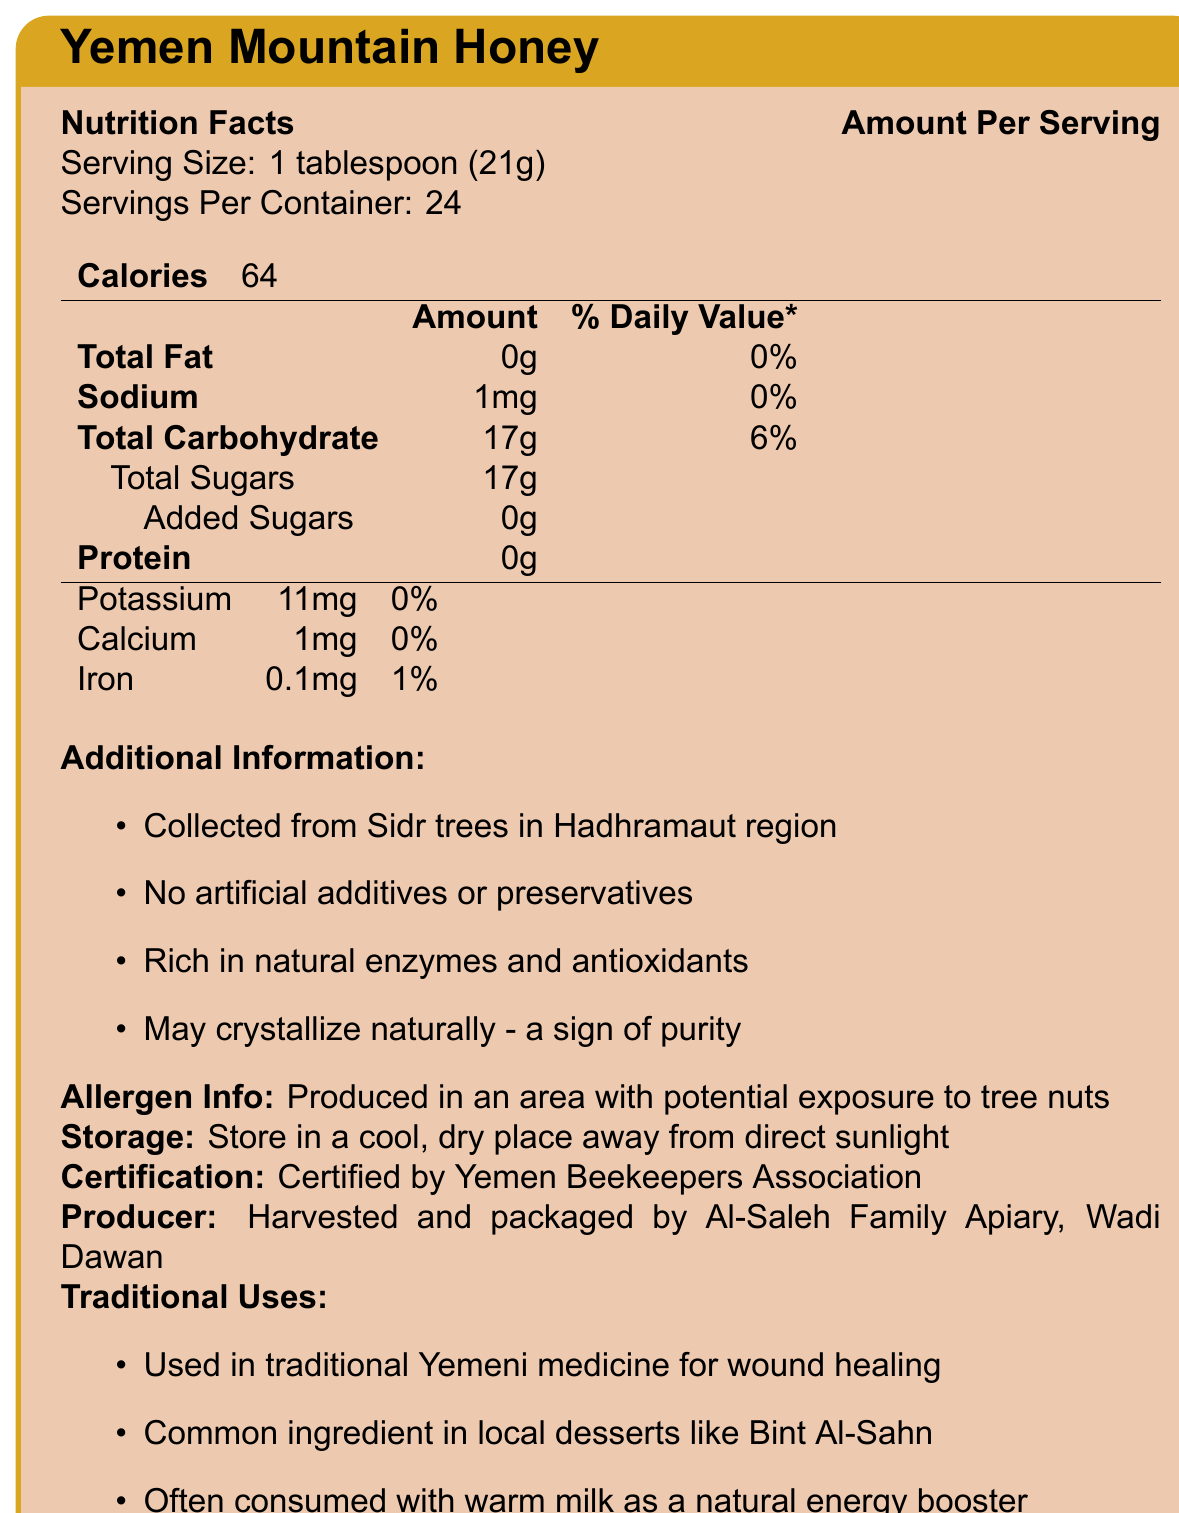what is the serving size for Yemen Mountain Honey? The serving size is clearly stated in the nutrition facts section as "1 tablespoon (21g)".
Answer: 1 tablespoon (21g) how many servings are in one container? The number of servings per container is given in the document as 24.
Answer: 24 servings what is the amount of total sugars per serving? The amount of total sugars per serving is listed as 17g in the nutrition facts.
Answer: 17g is there any added sugar in Yemen Mountain Honey? The document specifies that there are 0g of added sugars in the honey.
Answer: No what is the main source of this honey? The additional information section mentions that the honey is collected from Sidr trees in the Hadhramaut region.
Answer: Sidr trees in Hadhramaut region The production of Yemen Mountain Honey is associated with potential exposure to which allergen? A. Dairy B. Tree nuts C. Gluten The allergen information states that the honey is produced in an area with potential exposure to tree nuts.
Answer: B. Tree nuts how many milligrams of potassium are there per serving? The amount of potassium per serving is indicated as 11mg in the nutrition facts.
Answer: 11mg Yemen Mountain Honey is certified by which association? A. Yemeni Farmers Association B. Yemen Beekeepers Association C. Yemeni Organic Producers Association The certification section states that the honey is certified by the Yemen Beekeepers Association.
Answer: B. Yemen Beekeepers Association is there any protein in Yemen Mountain Honey? The nutrition facts indicate that there is 0g of protein per serving.
Answer: No what are some traditional uses of Yemen Mountain Honey? The document lists these traditional uses in the traditional uses section.
Answer: Used in traditional Yemeni medicine for wound healing, common ingredient in local desserts like Bint Al-Sahn, often consumed with warm milk as a natural energy booster what should be the storage conditions for Yemen Mountain Honey? The storage instructions mention that the honey should be stored in a cool, dry place away from direct sunlight.
Answer: Store in a cool, dry place away from direct sunlight what is the daily value percentage of iron in Yemen Mountain Honey? The amount of iron per serving is 0.1mg and the daily value percentage is listed as 1%.
Answer: 1% is this honey synthetic or does it have artificial additives or preservatives? The additional information section states that there are no artificial additives or preservatives in Yemen Mountain Honey.
Answer: No who harvests and packages Yemen Mountain Honey? The producer information mentions that the honey is harvested and packaged by Al-Saleh Family Apiary in Wadi Dawan.
Answer: Al-Saleh Family Apiary, Wadi Dawan what are the calories per serving of Yemen Mountain Honey? The document states that there are 64 calories per serving.
Answer: 64 calories what are the nutritional benefits of Yemen Mountain Honey? The additional information and vitamins and minerals sections highlight these nutritional benefits.
Answer: Rich in natural enzymes and antioxidants, contains minerals like potassium, calcium, and iron what is the total carbohydrate content per serving? The total carbohydrate content per serving is given as 17g in the nutrition facts.
Answer: 17g Does the honey contain fat? The amount of total fat per serving is listed as 0g in the nutrition facts, indicating there is no fat content.
Answer: No how much sodium is present in one serving? The nutrition facts indicate that there is 1mg of sodium per serving.
Answer: 1mg Summarize the main information presented in the document. The document is designed to give a complete overview ranging from nutritional information to production and traditional uses of Yemen Mountain Honey. It communicates the purity and health benefits of the honey along with its cultural significance.
Answer: The document provides comprehensive details about Yemen Mountain Honey. It includes nutrition facts, emphasizing its low sodium, fat-free, and high natural sugar content. The honey is sourced from Sidr trees in Hadhramaut, with no artificial additives, and is rich in natural enzymes and antioxidants. The document also covers storage instructions, allergen information, traditional uses, and certification by the Yemen Beekeepers Association. It is harvested and packaged by Al-Saleh Family Apiary in Wadi Dawan. what is the significance of honey crystallization as per the document? The additional information section states that crystallization is a sign of purity.
Answer: A sign of purity 